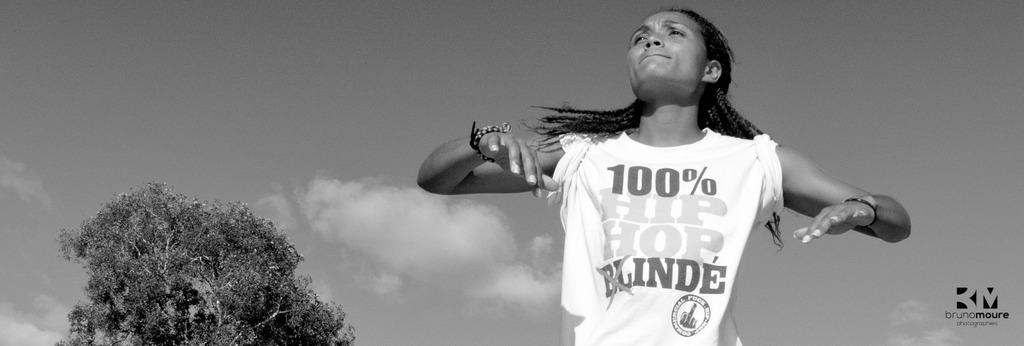Who or what is present in the image? There is a person in the image. What is the color scheme of the image? The image is black and white. What can be seen on the left side of the image? There is a tree on the left side of the image. What is visible in the background of the image? The sky is visible in the background of the image. How many times does the tree laugh in the image? There is no tree present in the image, and trees do not have the ability to laugh. 